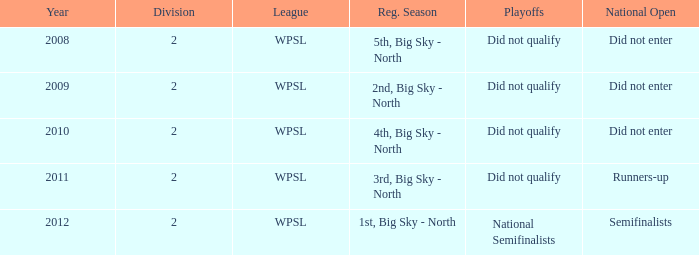What association was engaged in 2010? WPSL. 